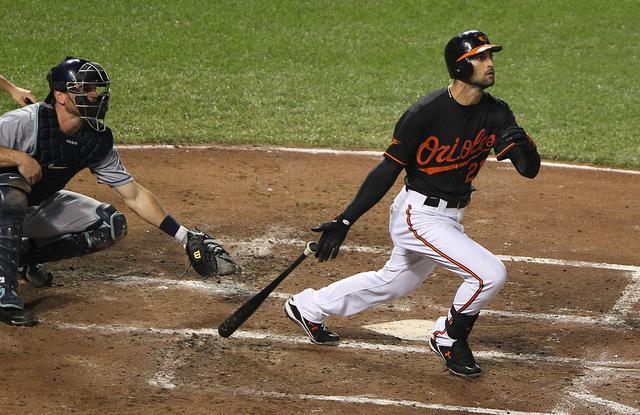How many hands is on the bat?
Give a very brief answer. 0. How many people are in the photo?
Give a very brief answer. 2. How many birds are there?
Give a very brief answer. 0. 